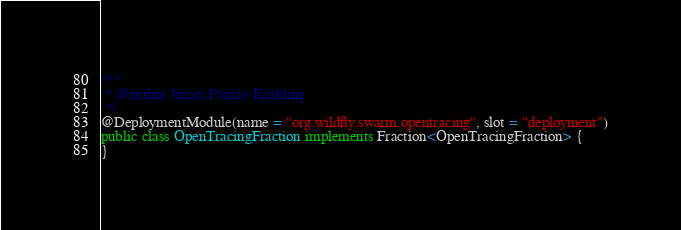Convert code to text. <code><loc_0><loc_0><loc_500><loc_500><_Java_>/**
 * @author Juraci Paixão Kröhling
 */
@DeploymentModule(name = "org.wildfly.swarm.opentracing", slot = "deployment")
public class OpenTracingFraction implements Fraction<OpenTracingFraction> {
}
</code> 